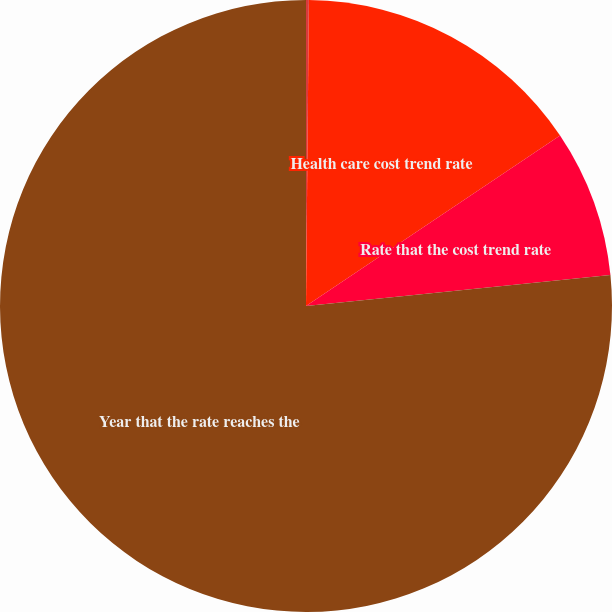Convert chart to OTSL. <chart><loc_0><loc_0><loc_500><loc_500><pie_chart><fcel>Discount rate<fcel>Health care cost trend rate<fcel>Rate that the cost trend rate<fcel>Year that the rate reaches the<nl><fcel>0.15%<fcel>15.44%<fcel>7.8%<fcel>76.61%<nl></chart> 